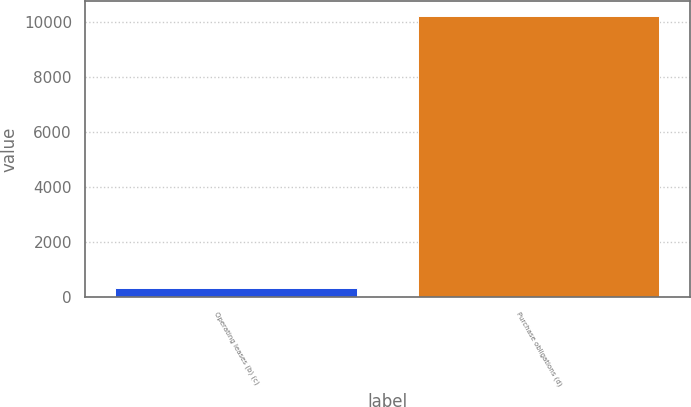Convert chart. <chart><loc_0><loc_0><loc_500><loc_500><bar_chart><fcel>Operating leases (b) (c)<fcel>Purchase obligations (d)<nl><fcel>359<fcel>10236<nl></chart> 